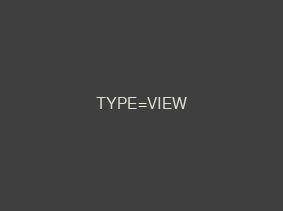<code> <loc_0><loc_0><loc_500><loc_500><_VisualBasic_>TYPE=VIEW</code> 